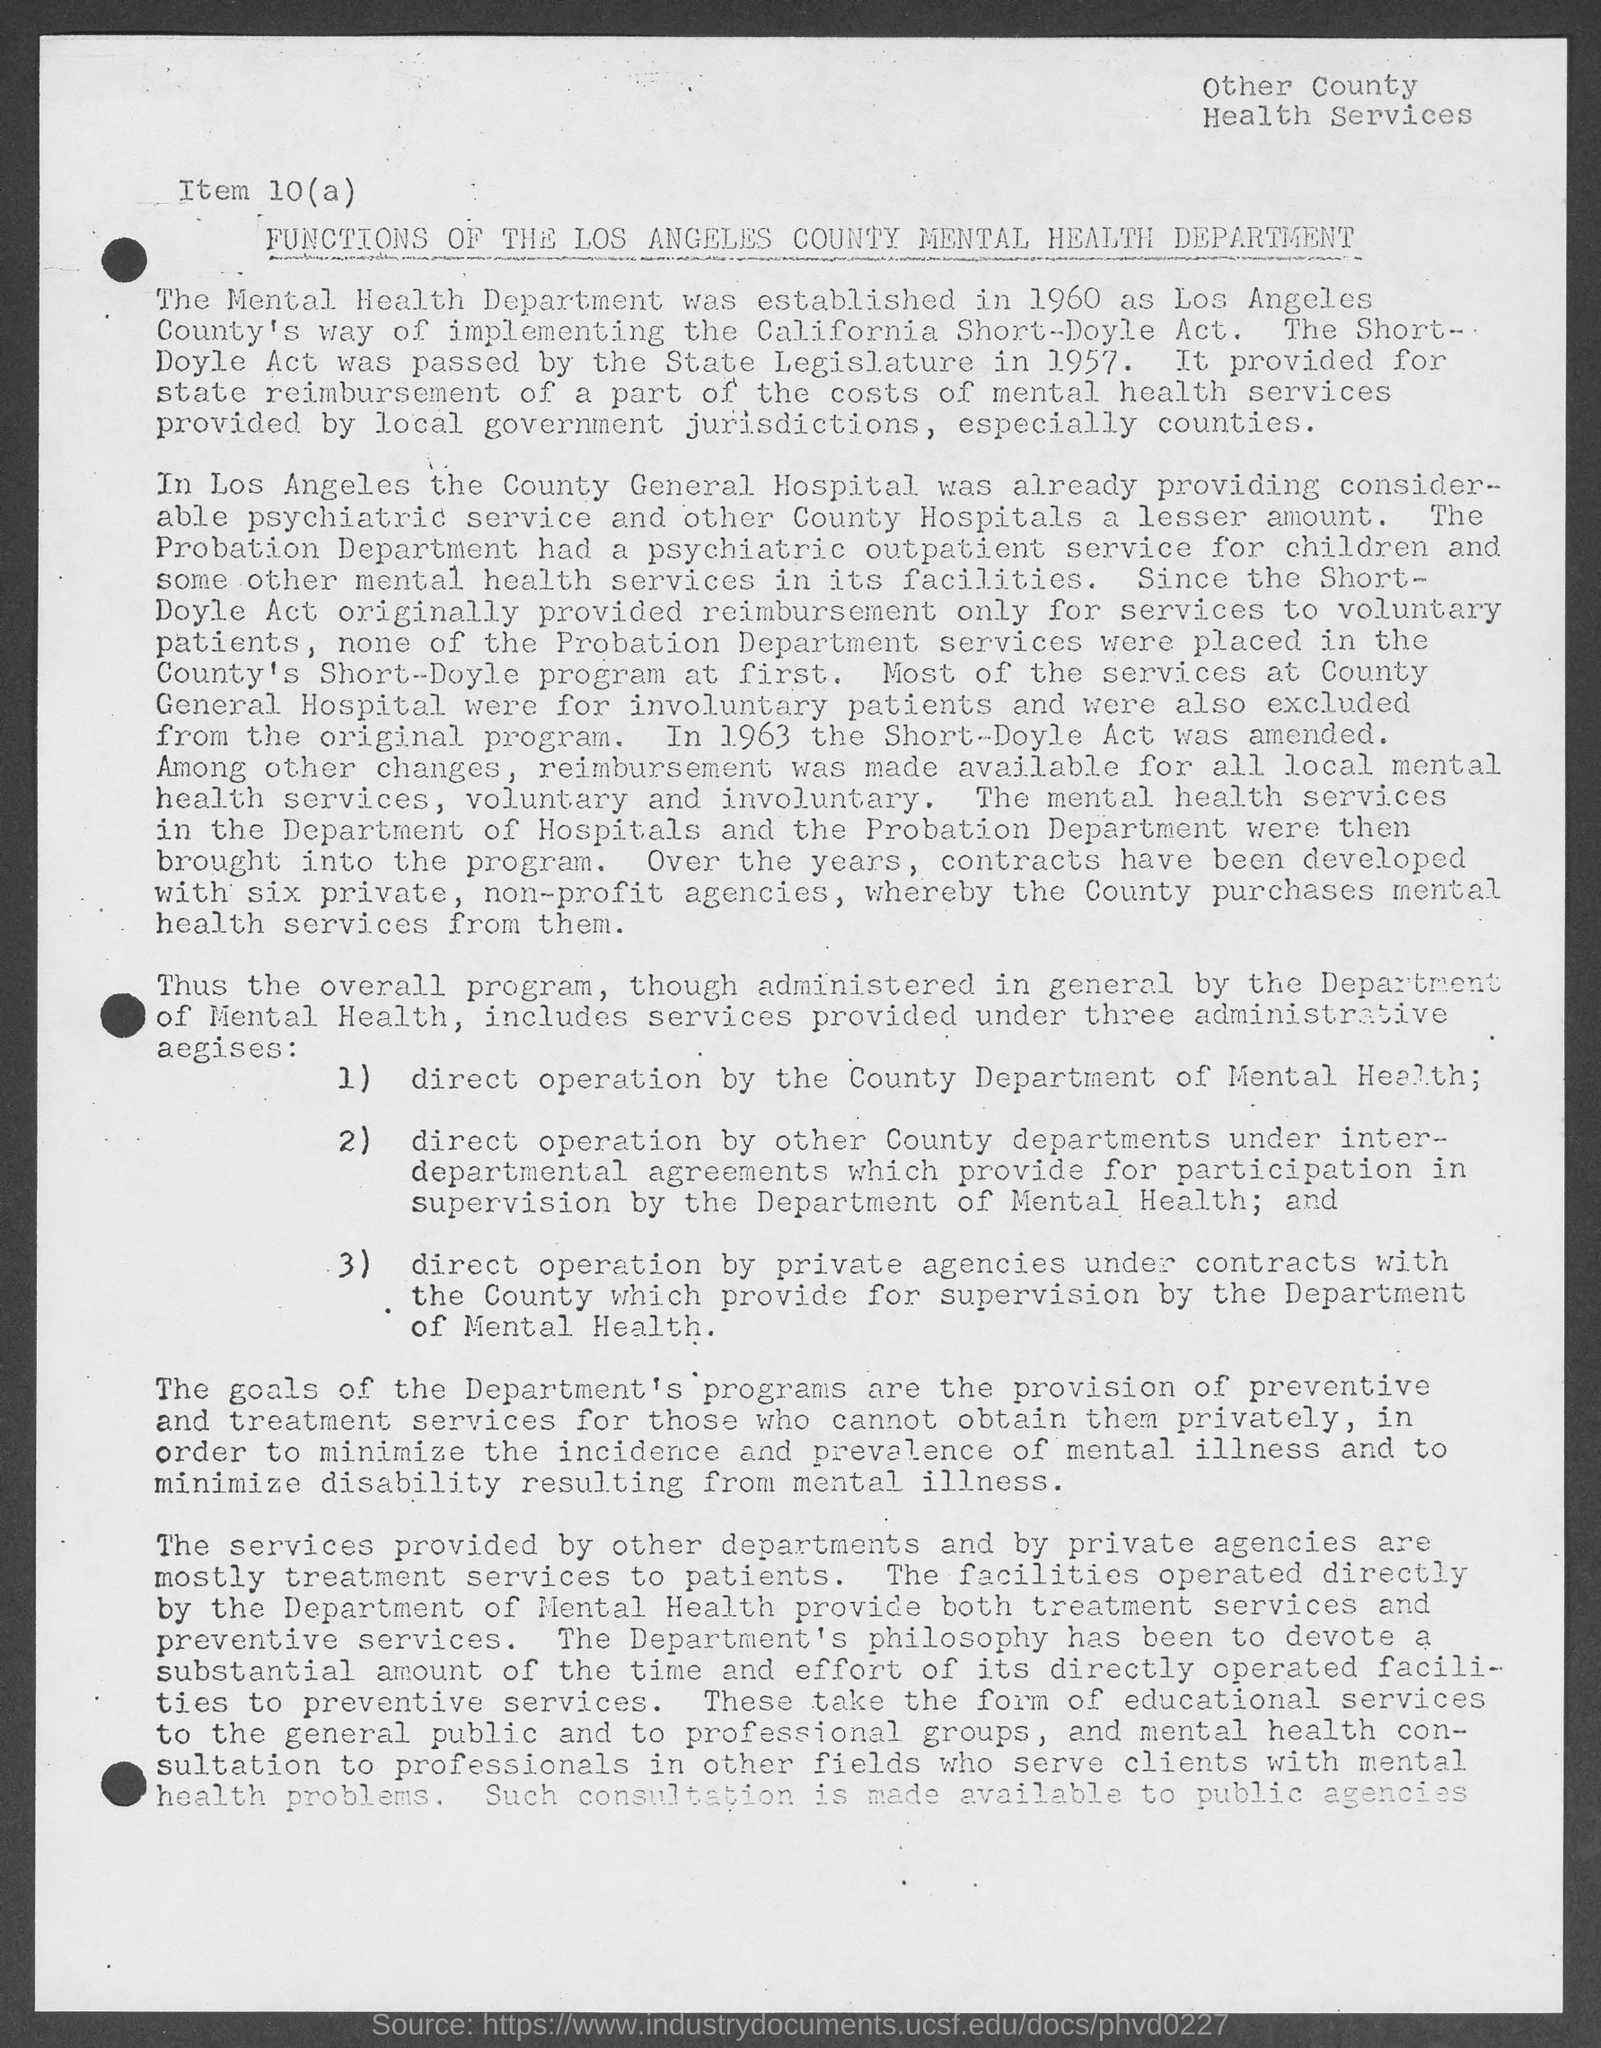Highlight a few significant elements in this photo. The State Legislature passed the Short-Doyle Act in the year 1957. The Short-Doyle Act was amended in 1963. The Mental Health Department was established in the year 1960. The Short-Doyle Act initially reimbursed services for voluntary patients. The probation department had a psychiatric outpatient service for children. 